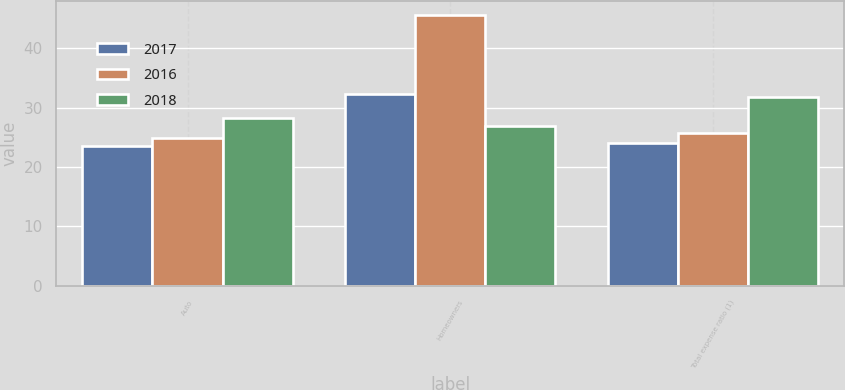<chart> <loc_0><loc_0><loc_500><loc_500><stacked_bar_chart><ecel><fcel>Auto<fcel>Homeowners<fcel>Total expense ratio (1)<nl><fcel>2017<fcel>23.6<fcel>32.2<fcel>24.1<nl><fcel>2016<fcel>24.8<fcel>45.6<fcel>25.7<nl><fcel>2018<fcel>28.2<fcel>26.95<fcel>31.7<nl></chart> 